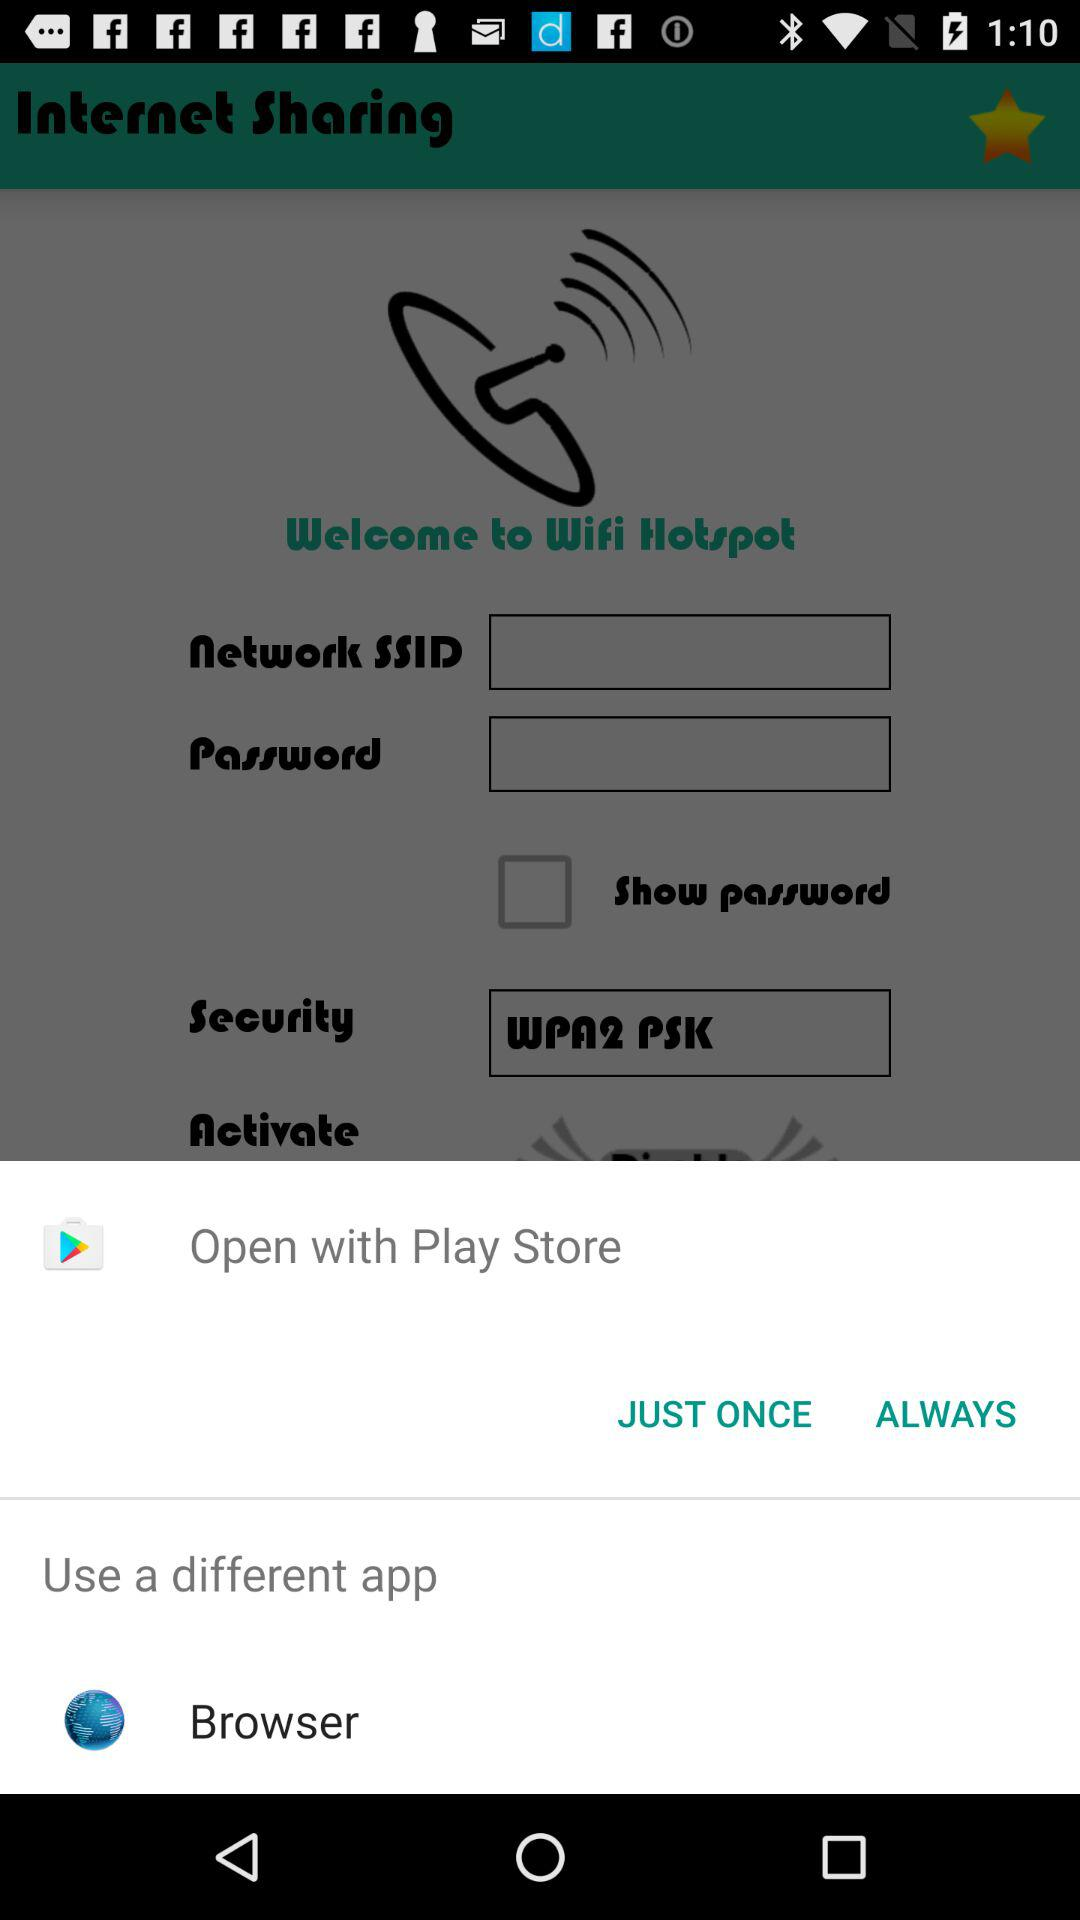What are the different application options to open with? The different application options are "Play Store" and "Browser". 